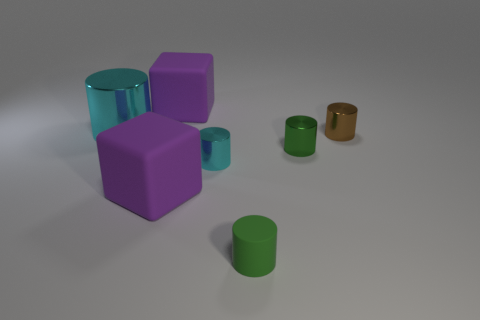What number of small objects are either cyan metal cylinders or green things?
Provide a short and direct response. 3. What size is the other thing that is the same color as the big metallic thing?
Offer a very short reply. Small. Is there a cyan sphere made of the same material as the brown cylinder?
Your response must be concise. No. There is a tiny green object to the left of the small green shiny cylinder; what is it made of?
Provide a short and direct response. Rubber. There is a small cylinder to the left of the rubber cylinder; does it have the same color as the metal object to the left of the tiny cyan metallic object?
Your answer should be compact. Yes. What is the color of the rubber cylinder that is the same size as the brown metal cylinder?
Offer a terse response. Green. How many other things are the same shape as the big metal object?
Provide a succinct answer. 4. There is a green thing in front of the small cyan cylinder; what size is it?
Offer a very short reply. Small. How many cylinders are behind the tiny green cylinder to the left of the green metallic cylinder?
Ensure brevity in your answer.  4. What number of other things are the same size as the rubber cylinder?
Your answer should be very brief. 3. 